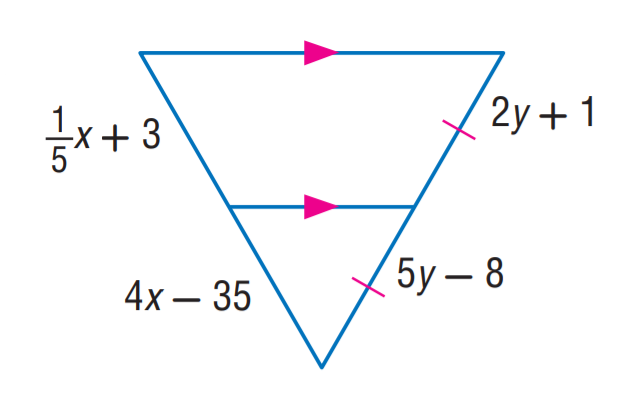Question: Find x.
Choices:
A. 5
B. 8
C. 10
D. 12
Answer with the letter. Answer: C Question: Find y.
Choices:
A. 1
B. 3
C. 5
D. 8
Answer with the letter. Answer: B 